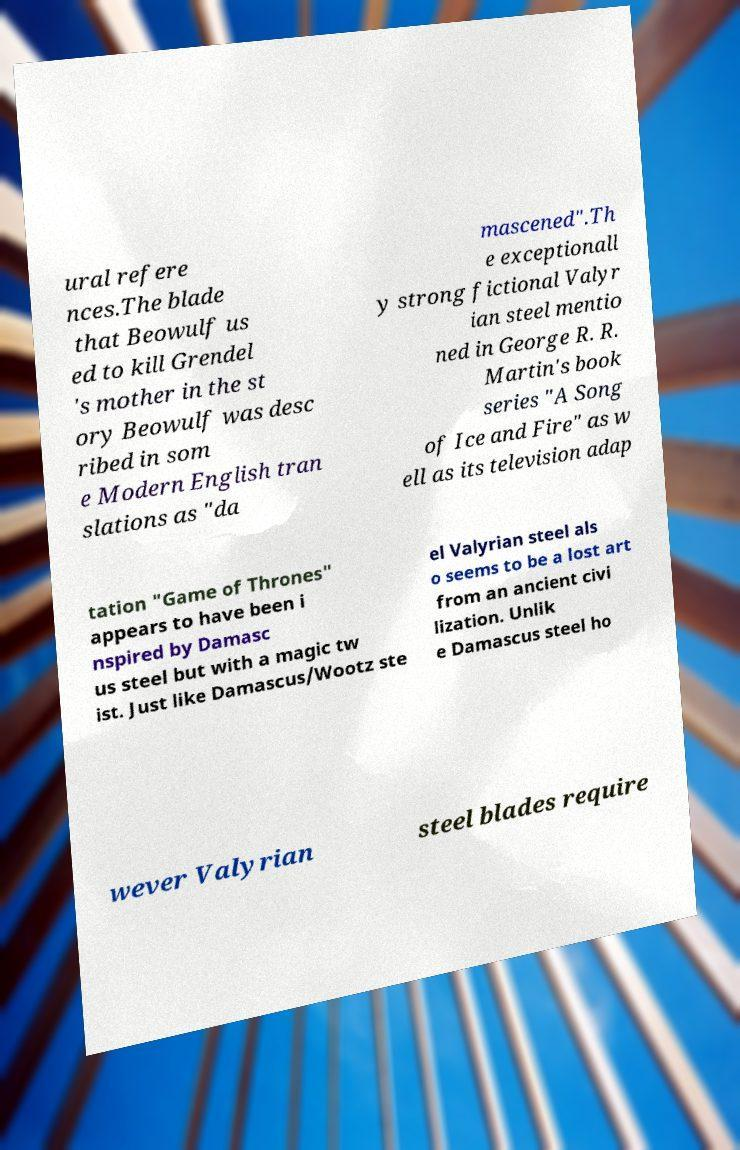There's text embedded in this image that I need extracted. Can you transcribe it verbatim? ural refere nces.The blade that Beowulf us ed to kill Grendel 's mother in the st ory Beowulf was desc ribed in som e Modern English tran slations as "da mascened".Th e exceptionall y strong fictional Valyr ian steel mentio ned in George R. R. Martin's book series "A Song of Ice and Fire" as w ell as its television adap tation "Game of Thrones" appears to have been i nspired by Damasc us steel but with a magic tw ist. Just like Damascus/Wootz ste el Valyrian steel als o seems to be a lost art from an ancient civi lization. Unlik e Damascus steel ho wever Valyrian steel blades require 